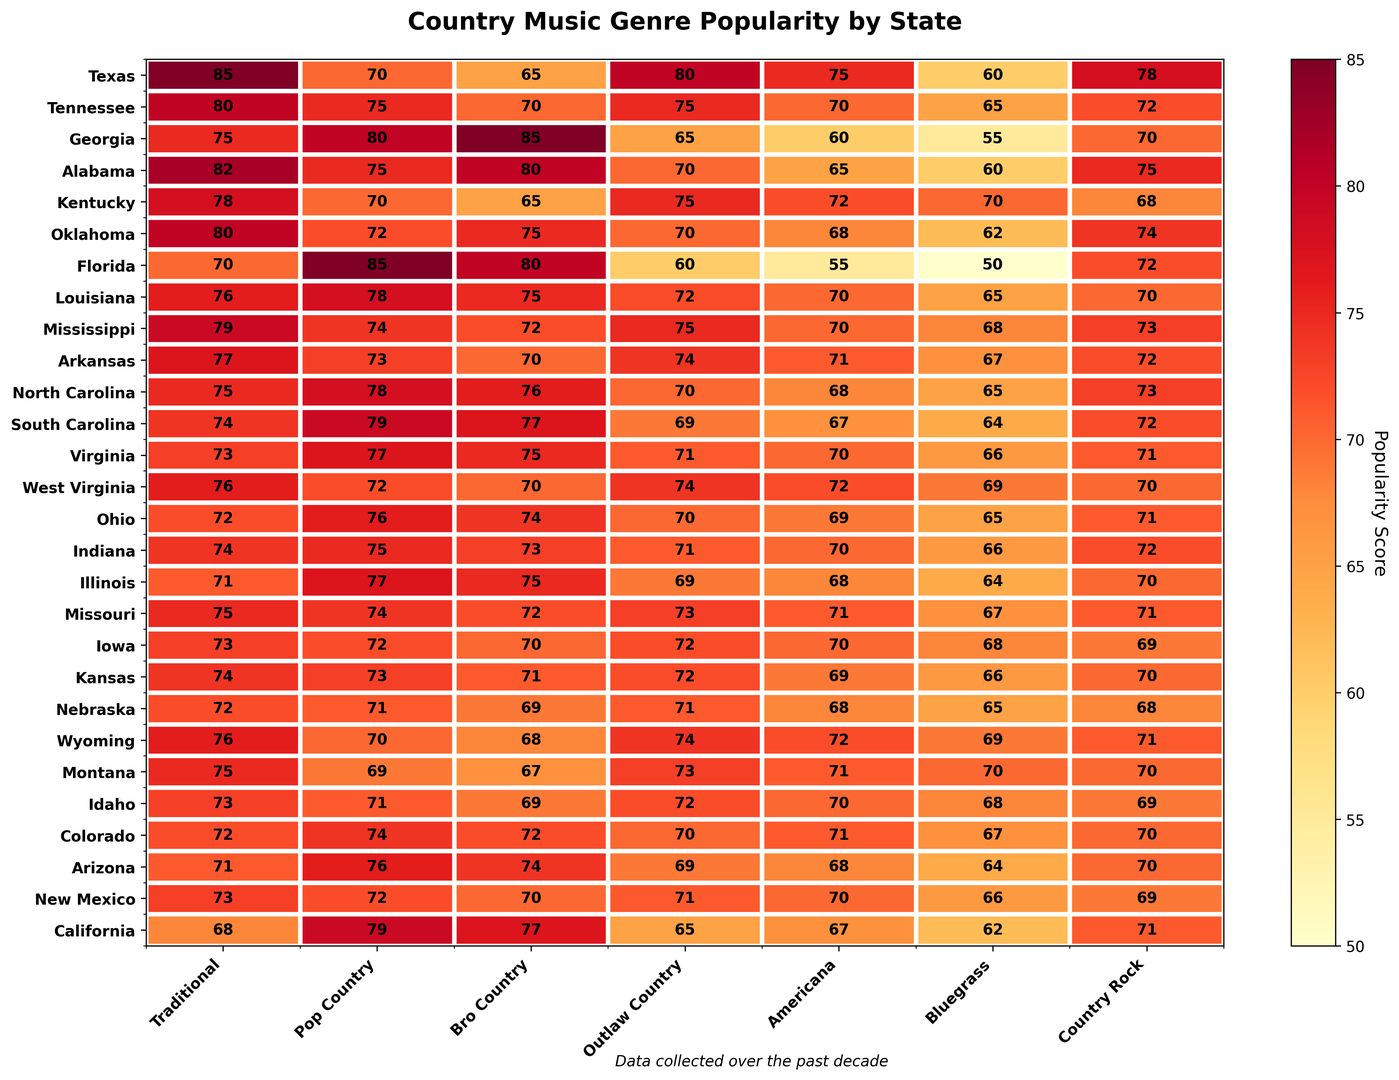Which state shows the highest popularity score for "Pop Country"? Looking at the rows representing the states and the column for "Pop Country", we observe the values. Florida has a score of 85, which is the highest among all states.
Answer: Florida Which genre is the least popular in Arkansas? For Arkansas, compare the scores across all genres. The minimum score is for "Bluegrass" with a value of 67.
Answer: Bluegrass What is the average popularity score of "Outlaw Country" for the states: Texas, Tennessee, and Georgia? Add the scores of "Outlaw Country" for Texas (80), Tennessee (75), and Georgia (65). Sum = 80 + 75 + 65 = 220. Average = 220 / 3 = 73.33.
Answer: 73.33 Which state has a higher popularity for "Traditional": Alabama or Oklahoma? Comparing the scores in the "Traditional" column for Alabama (82) and Oklahoma (80), we see Alabama has the higher score.
Answer: Alabama Which genre has the most consistent popularity across all states (i.e., the smallest range between the highest and lowest scores)? Calculate the range (max - min) for each genre's popularity values. "Pop Country" has scores ranging from 70 to 85 with a range of 15, which is the smallest range compared to other genres.
Answer: Pop Country Between the years 2013 and 2022, did the popularity of "Country Rock" in Iowa increase or decrease? Observe the "Country Rock" scores for Iowa. In 2013 it was 69, and in 2022 it was 80. Since 80 > 69, it increased.
Answer: Increase What is the combined popularity score for "Bluegrass" in Kentucky and Louisiana? Sum the "Bluegrass" scores for Kentucky (70) and Louisiana (65). Combined score = 70 + 65 = 135.
Answer: 135 How does the average popularity of "Americana" in the southern states (Alabama, Georgia, Florida) compare with that in the western states (California, Colorado, Arizona)? Calculate the average popularity of "Americana" in the southern states: (65+60+55)/3 = 60. Calculate the average in the western states: (67+71+68)/3 ≈ 68.67. The western states have a higher average.
Answer: Western states have a higher average Which genre in Texas shows the most significant increase in popularity from 2013 to 2022? Compare the 2013 and 2022 scores for each genre in Texas: Traditional (85 to 85), Pop Country (70 to 85), Bro Country (65 to 82), Outlaw Country (80 to 84), Americana (75 to 85), Bluegrass (60 to 83), Country Rock (78 to 85). "Bluegrass" shows the highest increase.
Answer: Bluegrass 